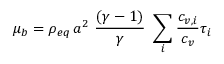Convert formula to latex. <formula><loc_0><loc_0><loc_500><loc_500>\mu _ { b } = \rho _ { e q } \, a ^ { 2 } \frac { ( \gamma - 1 ) } { \gamma } \sum _ { i } \frac { c _ { v , i } } { c _ { v } } \tau _ { i }</formula> 